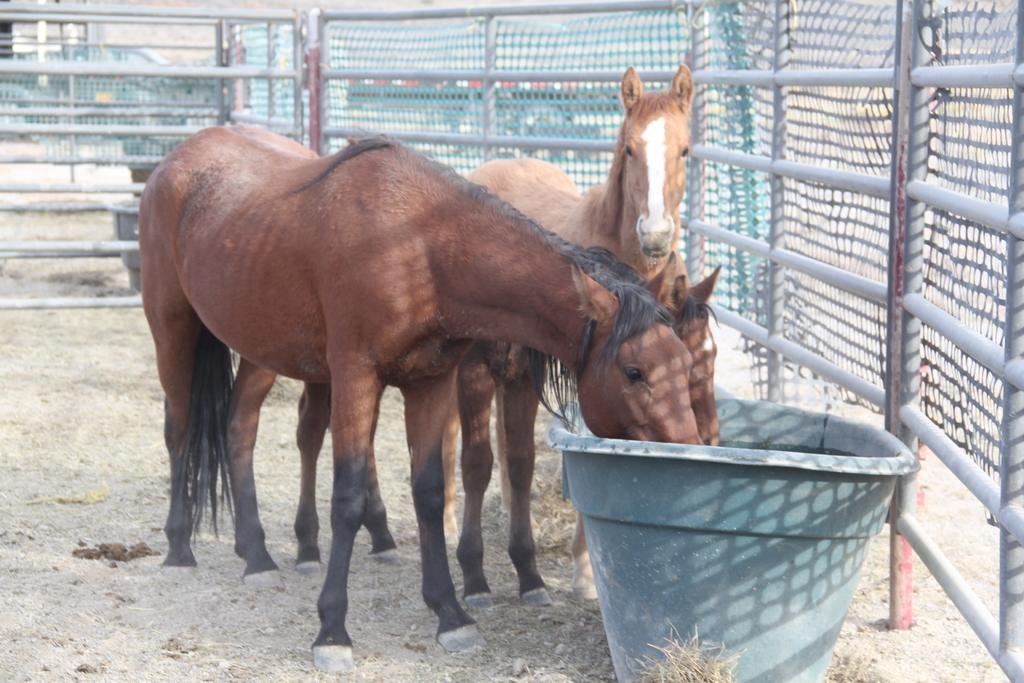How many horses are present in the image? There are 3 horses in the image. What is the color or appearance of the object near the horses? There is a grey object near the horses. What type of vegetation can be seen in the image? Grass is visible in the image. What can be seen in the background of the image? There is fencing in the background of the image. How many girls are holding a pie in the image? There are no girls or pies present in the image; it features 3 horses and a grey object. 